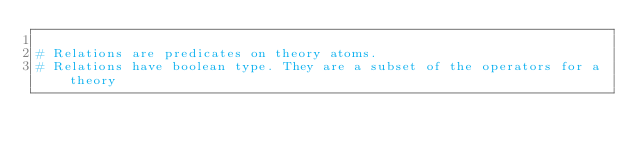Convert code to text. <code><loc_0><loc_0><loc_500><loc_500><_Python_>
# Relations are predicates on theory atoms.
# Relations have boolean type. They are a subset of the operators for a theory</code> 